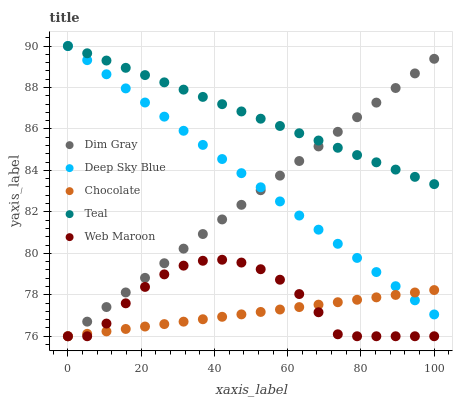Does Chocolate have the minimum area under the curve?
Answer yes or no. Yes. Does Teal have the maximum area under the curve?
Answer yes or no. Yes. Does Web Maroon have the minimum area under the curve?
Answer yes or no. No. Does Web Maroon have the maximum area under the curve?
Answer yes or no. No. Is Teal the smoothest?
Answer yes or no. Yes. Is Web Maroon the roughest?
Answer yes or no. Yes. Is Web Maroon the smoothest?
Answer yes or no. No. Is Teal the roughest?
Answer yes or no. No. Does Dim Gray have the lowest value?
Answer yes or no. Yes. Does Teal have the lowest value?
Answer yes or no. No. Does Deep Sky Blue have the highest value?
Answer yes or no. Yes. Does Web Maroon have the highest value?
Answer yes or no. No. Is Web Maroon less than Teal?
Answer yes or no. Yes. Is Deep Sky Blue greater than Web Maroon?
Answer yes or no. Yes. Does Deep Sky Blue intersect Chocolate?
Answer yes or no. Yes. Is Deep Sky Blue less than Chocolate?
Answer yes or no. No. Is Deep Sky Blue greater than Chocolate?
Answer yes or no. No. Does Web Maroon intersect Teal?
Answer yes or no. No. 